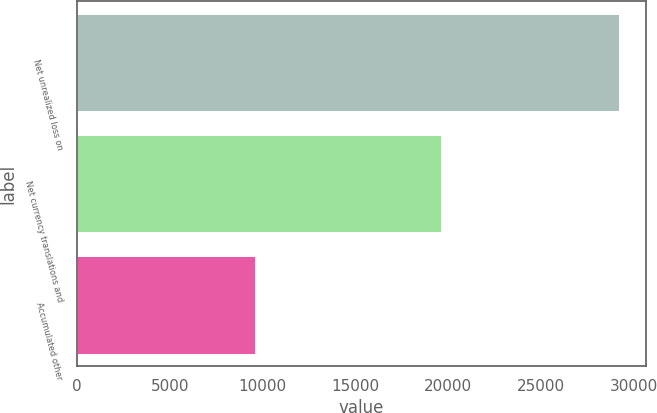Convert chart to OTSL. <chart><loc_0><loc_0><loc_500><loc_500><bar_chart><fcel>Net unrealized loss on<fcel>Net currency translations and<fcel>Accumulated other<nl><fcel>29204<fcel>19599<fcel>9605<nl></chart> 